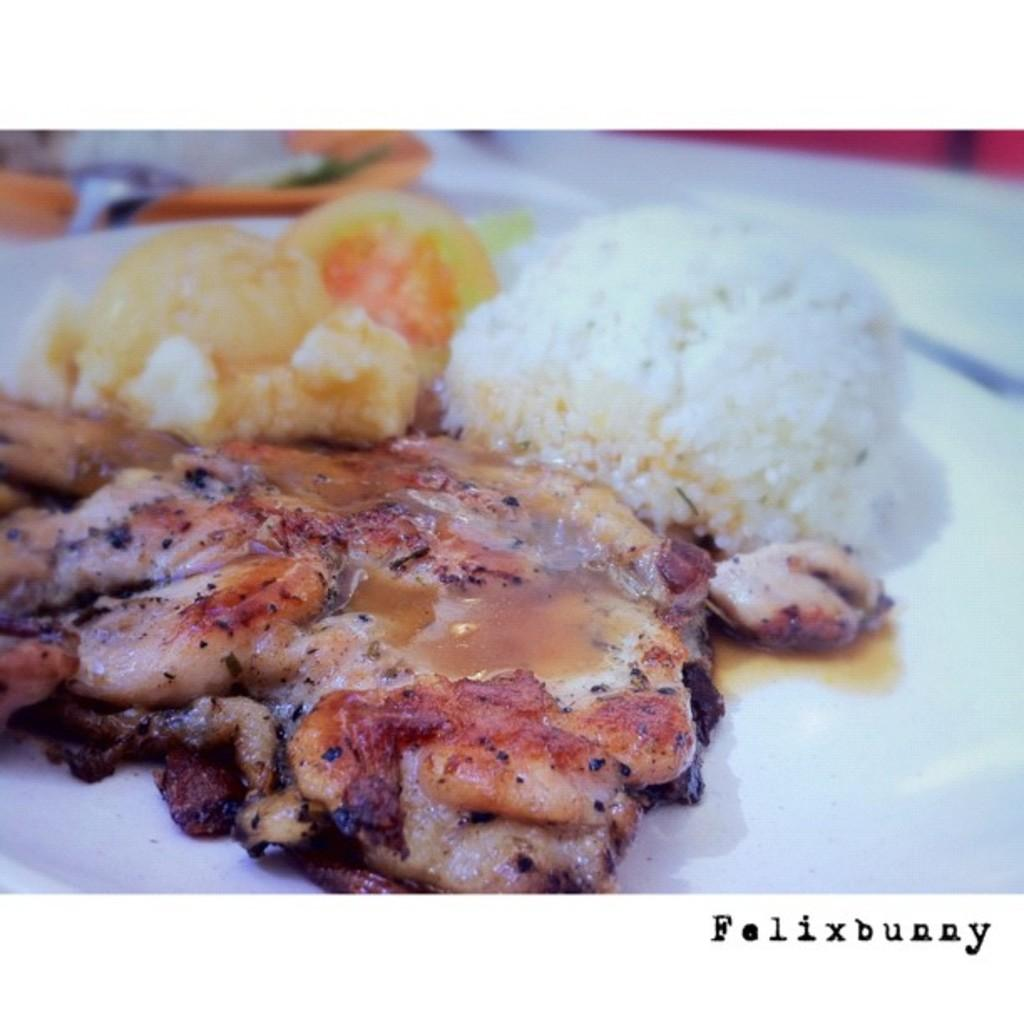What type of food is on the plate in the image? There is meat on the plate in the image. Are there any other food items on the plate? Yes, there are other food items on the plate in the image. What color is the plate? The plate is white in color. Is there any additional information about the image? Yes, there is a watermark on the image. Can you see a leaf on the plate in the image? No, there is no leaf present on the plate in the image. Is the meat on the plate being eaten or bitten in the image? The image does not show the meat being eaten or bitten; it is simply displayed on the plate. 